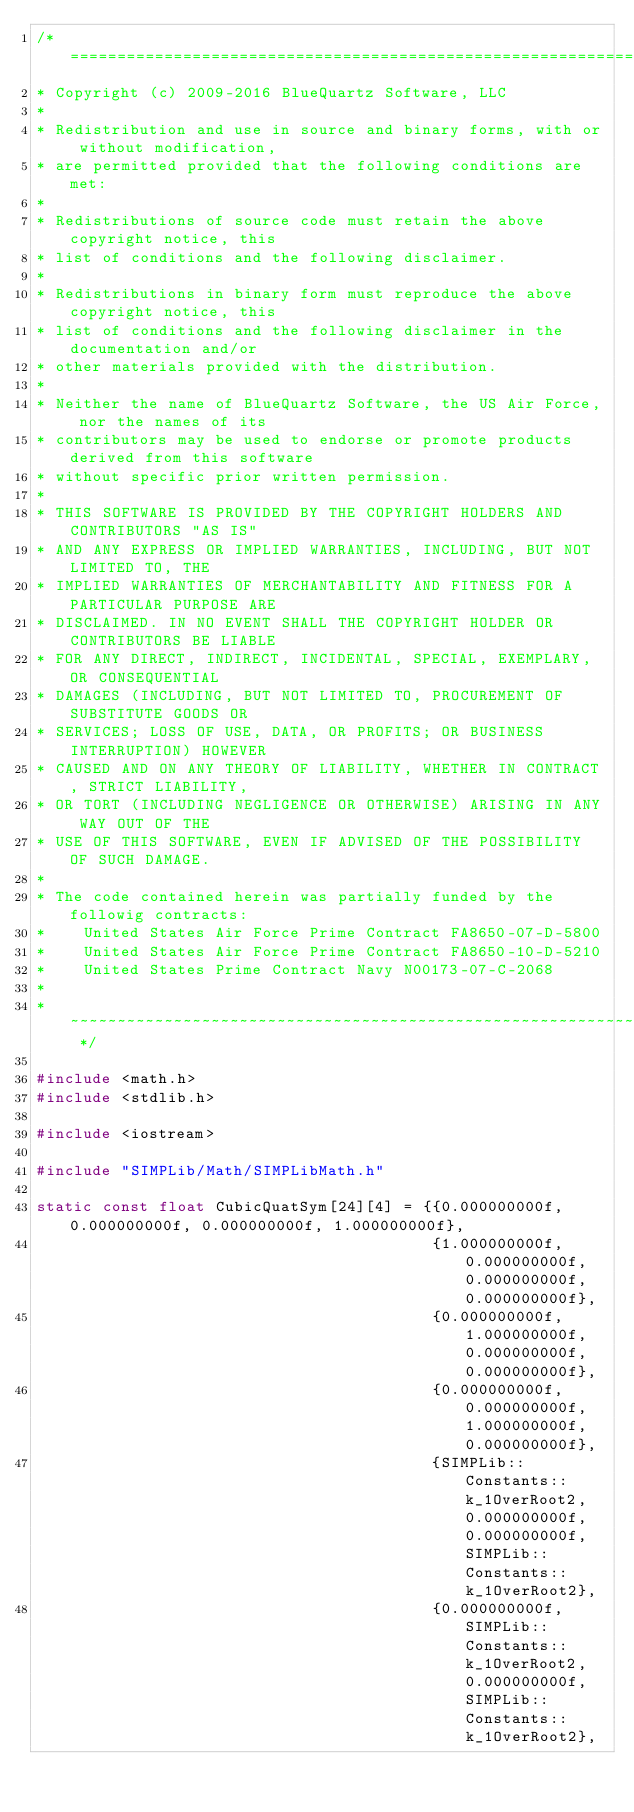Convert code to text. <code><loc_0><loc_0><loc_500><loc_500><_C++_>/* ============================================================================
* Copyright (c) 2009-2016 BlueQuartz Software, LLC
*
* Redistribution and use in source and binary forms, with or without modification,
* are permitted provided that the following conditions are met:
*
* Redistributions of source code must retain the above copyright notice, this
* list of conditions and the following disclaimer.
*
* Redistributions in binary form must reproduce the above copyright notice, this
* list of conditions and the following disclaimer in the documentation and/or
* other materials provided with the distribution.
*
* Neither the name of BlueQuartz Software, the US Air Force, nor the names of its
* contributors may be used to endorse or promote products derived from this software
* without specific prior written permission.
*
* THIS SOFTWARE IS PROVIDED BY THE COPYRIGHT HOLDERS AND CONTRIBUTORS "AS IS"
* AND ANY EXPRESS OR IMPLIED WARRANTIES, INCLUDING, BUT NOT LIMITED TO, THE
* IMPLIED WARRANTIES OF MERCHANTABILITY AND FITNESS FOR A PARTICULAR PURPOSE ARE
* DISCLAIMED. IN NO EVENT SHALL THE COPYRIGHT HOLDER OR CONTRIBUTORS BE LIABLE
* FOR ANY DIRECT, INDIRECT, INCIDENTAL, SPECIAL, EXEMPLARY, OR CONSEQUENTIAL
* DAMAGES (INCLUDING, BUT NOT LIMITED TO, PROCUREMENT OF SUBSTITUTE GOODS OR
* SERVICES; LOSS OF USE, DATA, OR PROFITS; OR BUSINESS INTERRUPTION) HOWEVER
* CAUSED AND ON ANY THEORY OF LIABILITY, WHETHER IN CONTRACT, STRICT LIABILITY,
* OR TORT (INCLUDING NEGLIGENCE OR OTHERWISE) ARISING IN ANY WAY OUT OF THE
* USE OF THIS SOFTWARE, EVEN IF ADVISED OF THE POSSIBILITY OF SUCH DAMAGE.
*
* The code contained herein was partially funded by the followig contracts:
*    United States Air Force Prime Contract FA8650-07-D-5800
*    United States Air Force Prime Contract FA8650-10-D-5210
*    United States Prime Contract Navy N00173-07-C-2068
*
* ~~~~~~~~~~~~~~~~~~~~~~~~~~~~~~~~~~~~~~~~~~~~~~~~~~~~~~~~~~~~~~~~~~~~~~~~~~ */

#include <math.h>
#include <stdlib.h>

#include <iostream>

#include "SIMPLib/Math/SIMPLibMath.h"

static const float CubicQuatSym[24][4] = {{0.000000000f, 0.000000000f, 0.000000000f, 1.000000000f},
                                          {1.000000000f, 0.000000000f, 0.000000000f, 0.000000000f},
                                          {0.000000000f, 1.000000000f, 0.000000000f, 0.000000000f},
                                          {0.000000000f, 0.000000000f, 1.000000000f, 0.000000000f},
                                          {SIMPLib::Constants::k_1OverRoot2, 0.000000000f, 0.000000000f, SIMPLib::Constants::k_1OverRoot2},
                                          {0.000000000f, SIMPLib::Constants::k_1OverRoot2, 0.000000000f, SIMPLib::Constants::k_1OverRoot2},</code> 